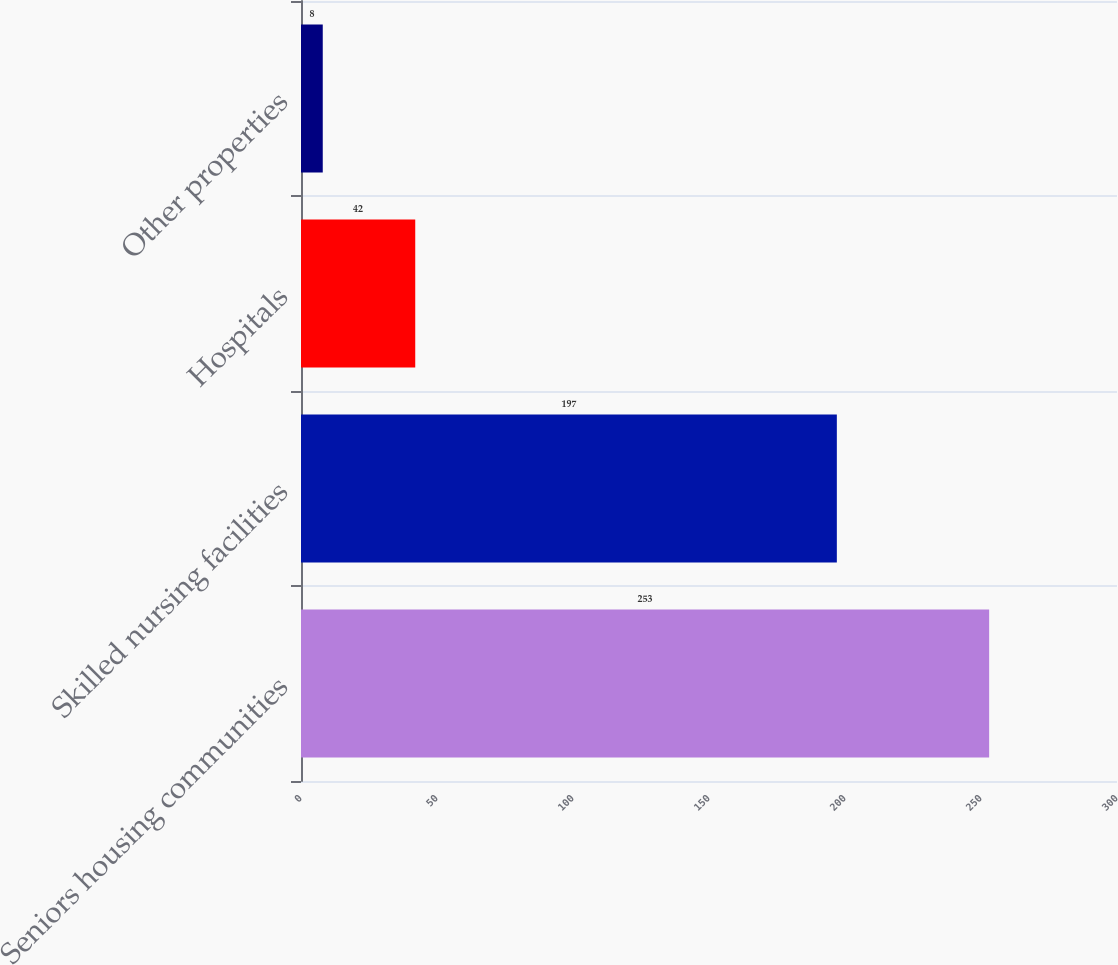Convert chart. <chart><loc_0><loc_0><loc_500><loc_500><bar_chart><fcel>Seniors housing communities<fcel>Skilled nursing facilities<fcel>Hospitals<fcel>Other properties<nl><fcel>253<fcel>197<fcel>42<fcel>8<nl></chart> 